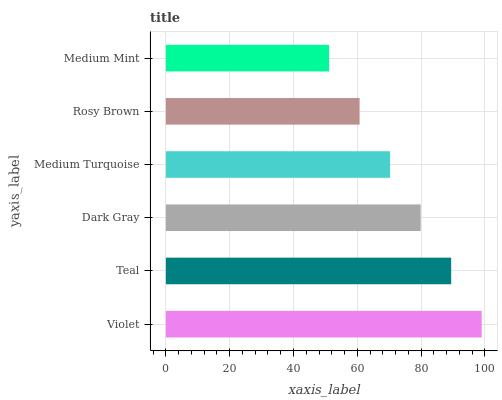Is Medium Mint the minimum?
Answer yes or no. Yes. Is Violet the maximum?
Answer yes or no. Yes. Is Teal the minimum?
Answer yes or no. No. Is Teal the maximum?
Answer yes or no. No. Is Violet greater than Teal?
Answer yes or no. Yes. Is Teal less than Violet?
Answer yes or no. Yes. Is Teal greater than Violet?
Answer yes or no. No. Is Violet less than Teal?
Answer yes or no. No. Is Dark Gray the high median?
Answer yes or no. Yes. Is Medium Turquoise the low median?
Answer yes or no. Yes. Is Teal the high median?
Answer yes or no. No. Is Dark Gray the low median?
Answer yes or no. No. 